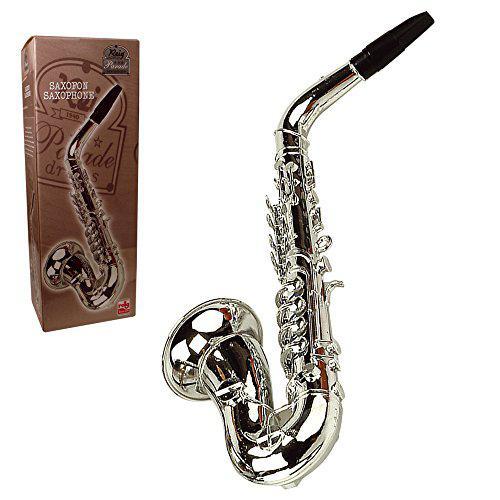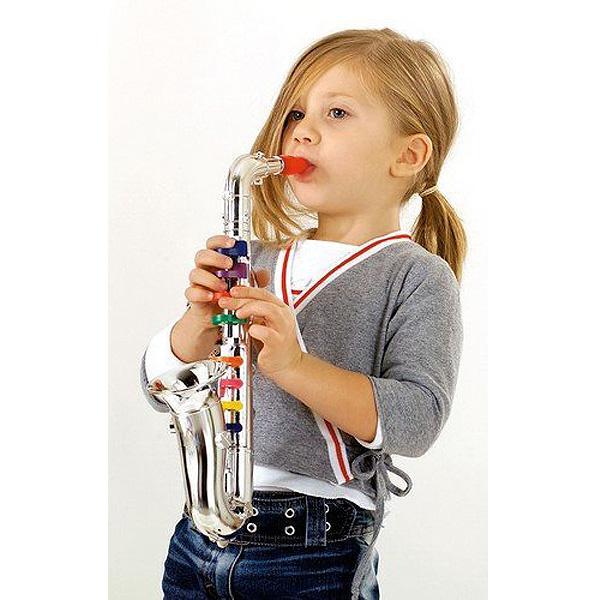The first image is the image on the left, the second image is the image on the right. For the images displayed, is the sentence "The right image contains a human child playing a saxophone." factually correct? Answer yes or no. Yes. The first image is the image on the left, the second image is the image on the right. For the images displayed, is the sentence "In one image, a child wearing jeans is leaning back as he or she plays a saxophone." factually correct? Answer yes or no. Yes. 